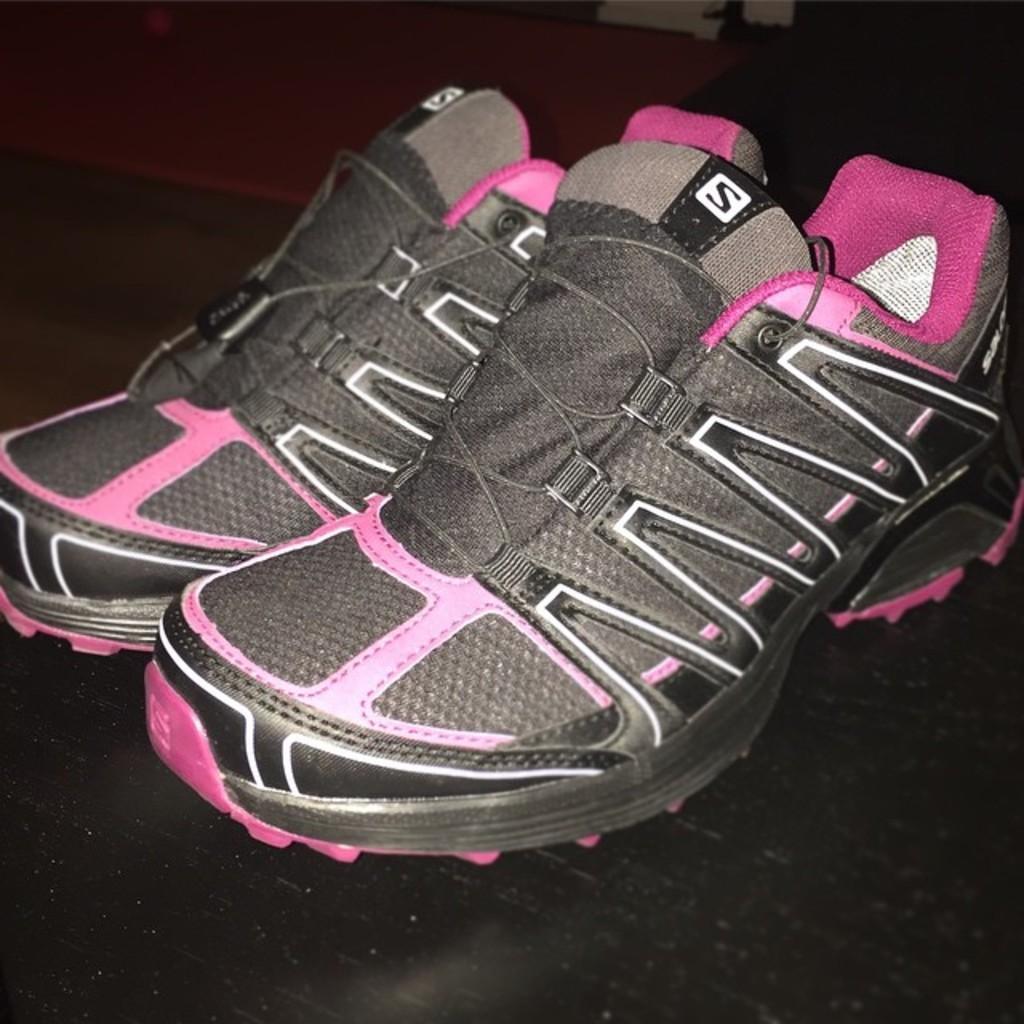Please provide a concise description of this image. In this image we can see a pair of shoes kept on the surface. 